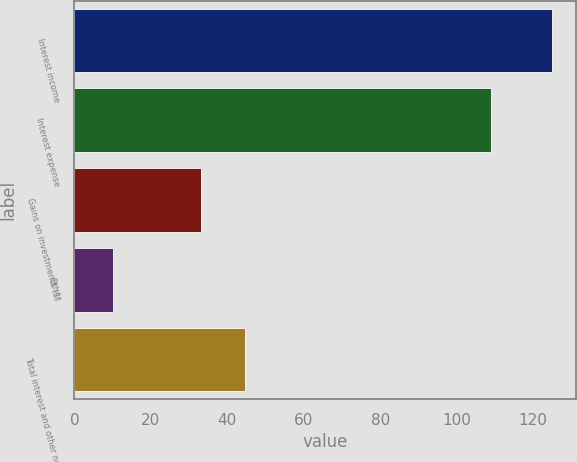Convert chart. <chart><loc_0><loc_0><loc_500><loc_500><bar_chart><fcel>Interest income<fcel>Interest expense<fcel>Gains on investments (1)<fcel>Other<fcel>Total interest and other net<nl><fcel>125<fcel>109<fcel>33<fcel>10<fcel>44.5<nl></chart> 